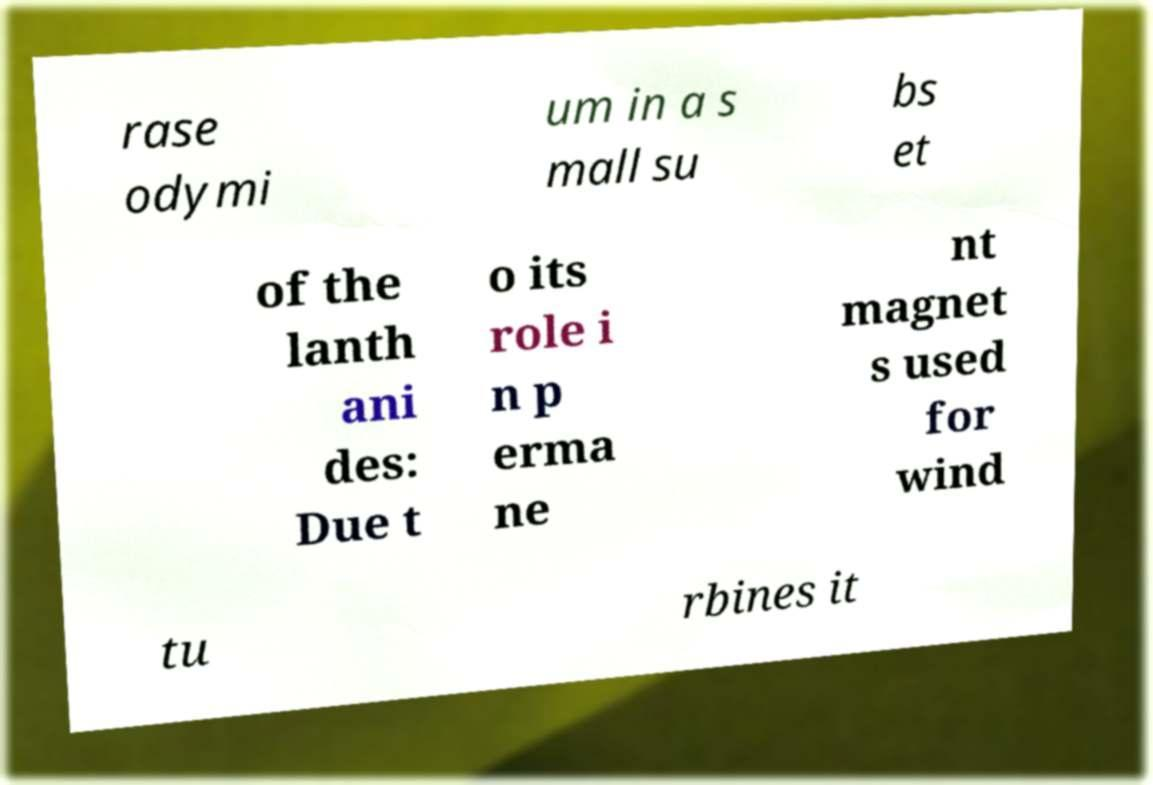Please identify and transcribe the text found in this image. rase odymi um in a s mall su bs et of the lanth ani des: Due t o its role i n p erma ne nt magnet s used for wind tu rbines it 